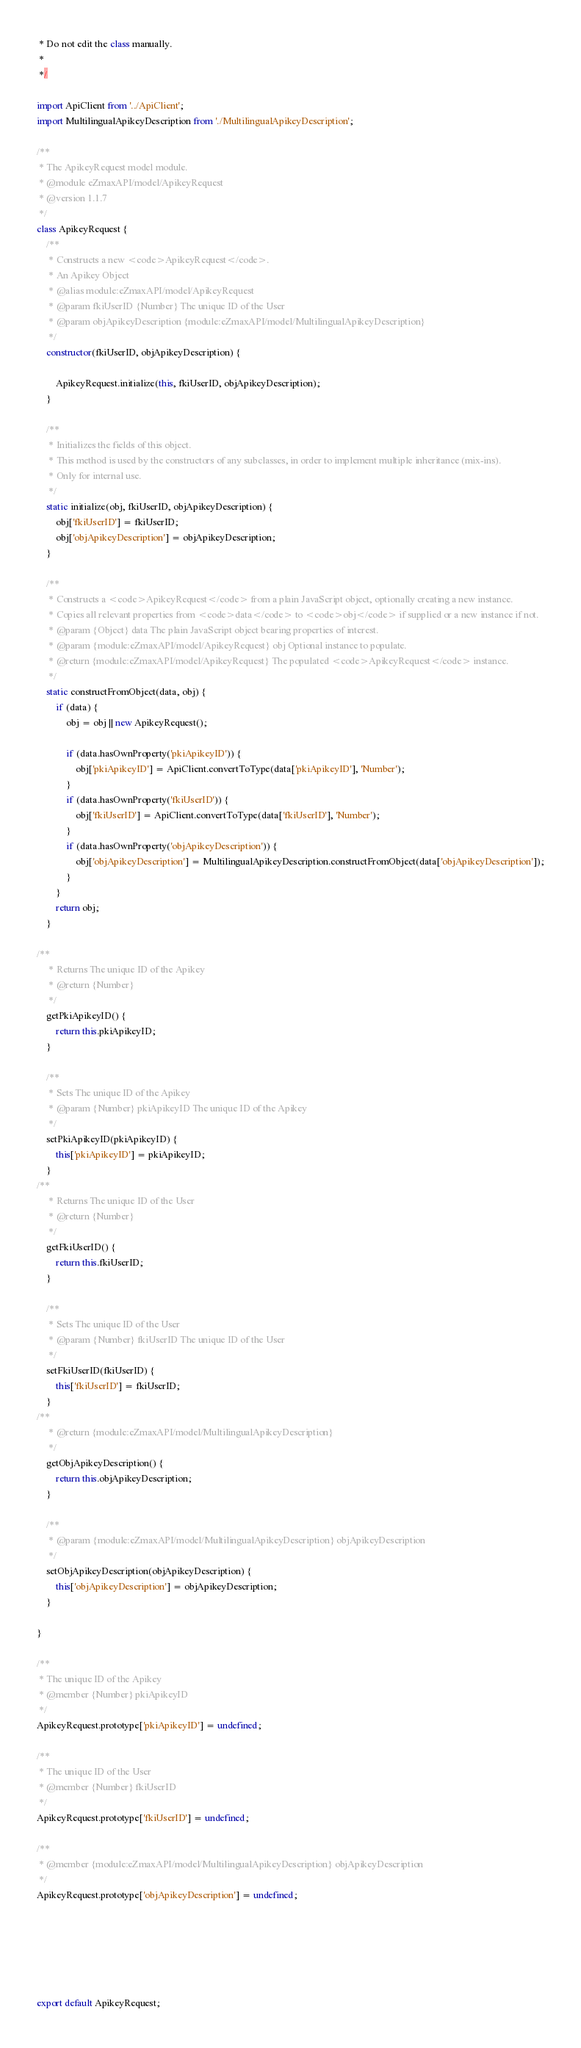<code> <loc_0><loc_0><loc_500><loc_500><_JavaScript_> * Do not edit the class manually.
 *
 */

import ApiClient from '../ApiClient';
import MultilingualApikeyDescription from './MultilingualApikeyDescription';

/**
 * The ApikeyRequest model module.
 * @module eZmaxAPI/model/ApikeyRequest
 * @version 1.1.7
 */
class ApikeyRequest {
    /**
     * Constructs a new <code>ApikeyRequest</code>.
     * An Apikey Object
     * @alias module:eZmaxAPI/model/ApikeyRequest
     * @param fkiUserID {Number} The unique ID of the User
     * @param objApikeyDescription {module:eZmaxAPI/model/MultilingualApikeyDescription} 
     */
    constructor(fkiUserID, objApikeyDescription) { 
        
        ApikeyRequest.initialize(this, fkiUserID, objApikeyDescription);
    }

    /**
     * Initializes the fields of this object.
     * This method is used by the constructors of any subclasses, in order to implement multiple inheritance (mix-ins).
     * Only for internal use.
     */
    static initialize(obj, fkiUserID, objApikeyDescription) { 
        obj['fkiUserID'] = fkiUserID;
        obj['objApikeyDescription'] = objApikeyDescription;
    }

    /**
     * Constructs a <code>ApikeyRequest</code> from a plain JavaScript object, optionally creating a new instance.
     * Copies all relevant properties from <code>data</code> to <code>obj</code> if supplied or a new instance if not.
     * @param {Object} data The plain JavaScript object bearing properties of interest.
     * @param {module:eZmaxAPI/model/ApikeyRequest} obj Optional instance to populate.
     * @return {module:eZmaxAPI/model/ApikeyRequest} The populated <code>ApikeyRequest</code> instance.
     */
    static constructFromObject(data, obj) {
        if (data) {
            obj = obj || new ApikeyRequest();

            if (data.hasOwnProperty('pkiApikeyID')) {
                obj['pkiApikeyID'] = ApiClient.convertToType(data['pkiApikeyID'], 'Number');
            }
            if (data.hasOwnProperty('fkiUserID')) {
                obj['fkiUserID'] = ApiClient.convertToType(data['fkiUserID'], 'Number');
            }
            if (data.hasOwnProperty('objApikeyDescription')) {
                obj['objApikeyDescription'] = MultilingualApikeyDescription.constructFromObject(data['objApikeyDescription']);
            }
        }
        return obj;
    }

/**
     * Returns The unique ID of the Apikey
     * @return {Number}
     */
    getPkiApikeyID() {
        return this.pkiApikeyID;
    }

    /**
     * Sets The unique ID of the Apikey
     * @param {Number} pkiApikeyID The unique ID of the Apikey
     */
    setPkiApikeyID(pkiApikeyID) {
        this['pkiApikeyID'] = pkiApikeyID;
    }
/**
     * Returns The unique ID of the User
     * @return {Number}
     */
    getFkiUserID() {
        return this.fkiUserID;
    }

    /**
     * Sets The unique ID of the User
     * @param {Number} fkiUserID The unique ID of the User
     */
    setFkiUserID(fkiUserID) {
        this['fkiUserID'] = fkiUserID;
    }
/**
     * @return {module:eZmaxAPI/model/MultilingualApikeyDescription}
     */
    getObjApikeyDescription() {
        return this.objApikeyDescription;
    }

    /**
     * @param {module:eZmaxAPI/model/MultilingualApikeyDescription} objApikeyDescription
     */
    setObjApikeyDescription(objApikeyDescription) {
        this['objApikeyDescription'] = objApikeyDescription;
    }

}

/**
 * The unique ID of the Apikey
 * @member {Number} pkiApikeyID
 */
ApikeyRequest.prototype['pkiApikeyID'] = undefined;

/**
 * The unique ID of the User
 * @member {Number} fkiUserID
 */
ApikeyRequest.prototype['fkiUserID'] = undefined;

/**
 * @member {module:eZmaxAPI/model/MultilingualApikeyDescription} objApikeyDescription
 */
ApikeyRequest.prototype['objApikeyDescription'] = undefined;






export default ApikeyRequest;

</code> 